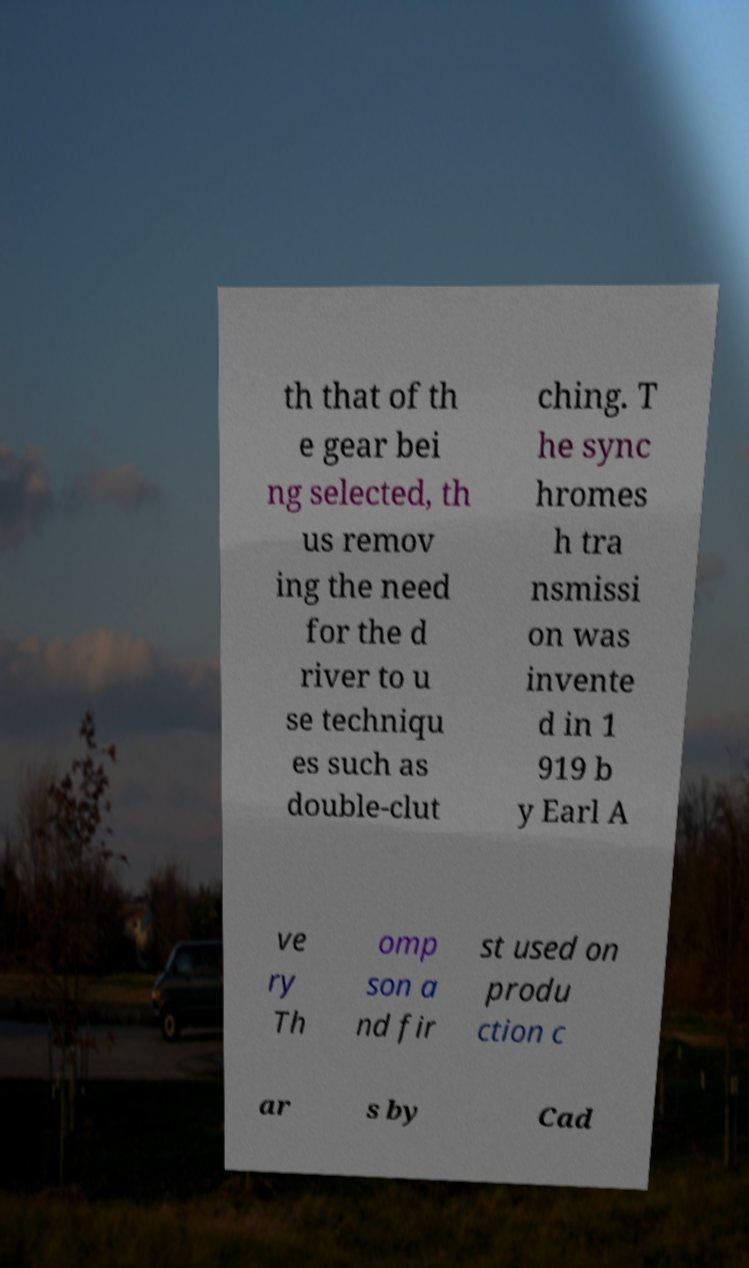For documentation purposes, I need the text within this image transcribed. Could you provide that? th that of th e gear bei ng selected, th us remov ing the need for the d river to u se techniqu es such as double-clut ching. T he sync hromes h tra nsmissi on was invente d in 1 919 b y Earl A ve ry Th omp son a nd fir st used on produ ction c ar s by Cad 